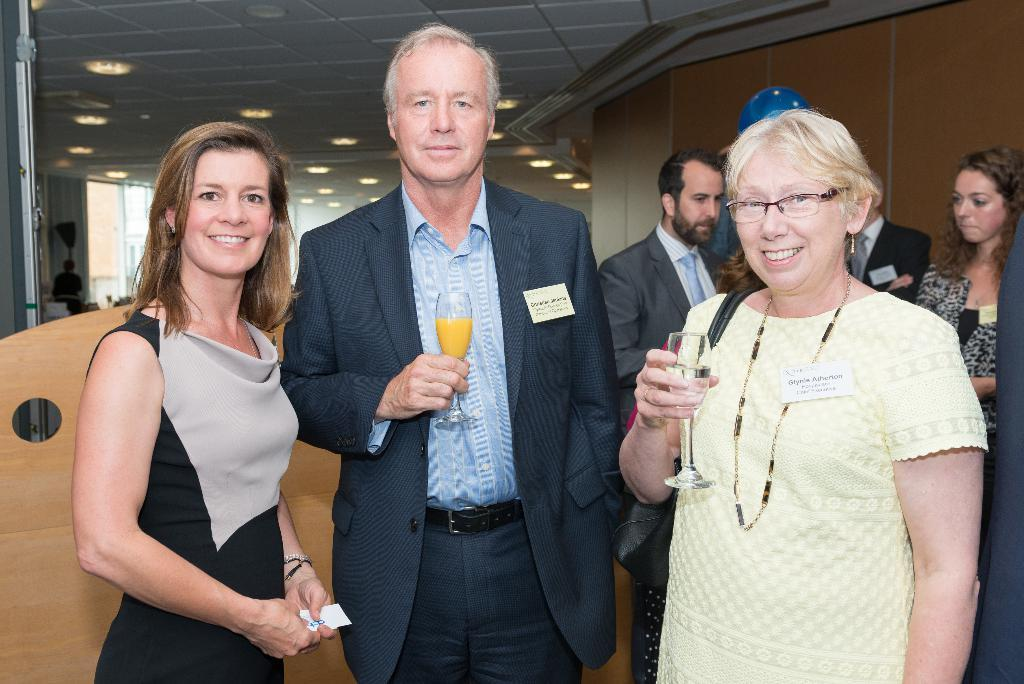What can be seen in the image? There are people standing in the image. What is visible in the background of the image? There is a wall in the background of the image. What is hanging from the ceiling in the image? Lights are attached to the ceiling in the image. What type of bread can be seen floating in space in the image? There is no bread or space present in the image; it features people standing with a wall in the background and lights attached to the ceiling. 